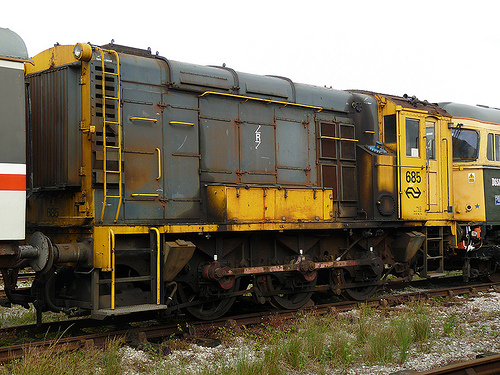Are there both cars and trains in this image? Yes, there are both cars and trains visible in the image. 